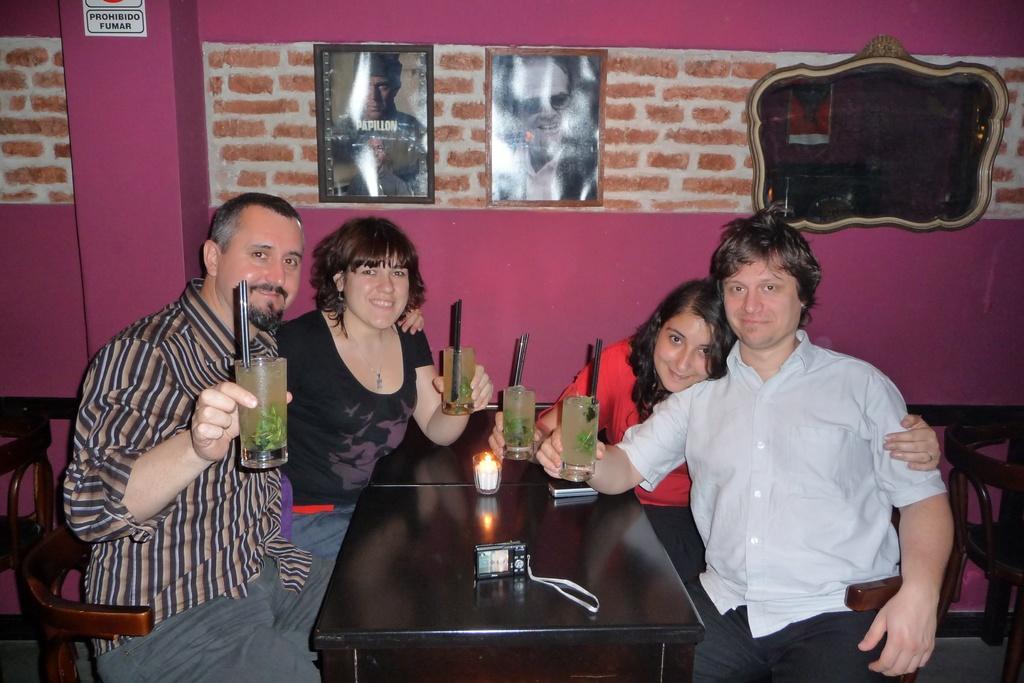Please provide a concise description of this image. There are four people in a room. They are sitting in a chair. There is a table. There is a glass,mobile and camera on a table. We can see in the background there is a red color wall bricks and photo frame. 